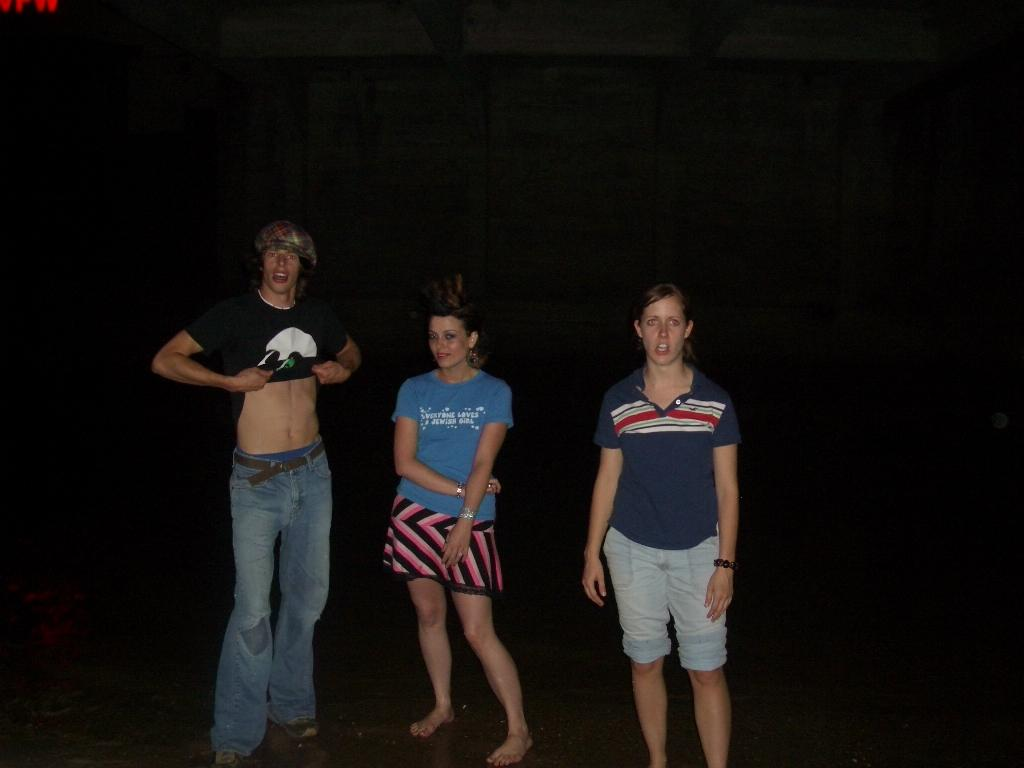<image>
Relay a brief, clear account of the picture shown. A man lifts his shirt next to a woman wearing a shirt that says "Everyone loves Jewish girls." 